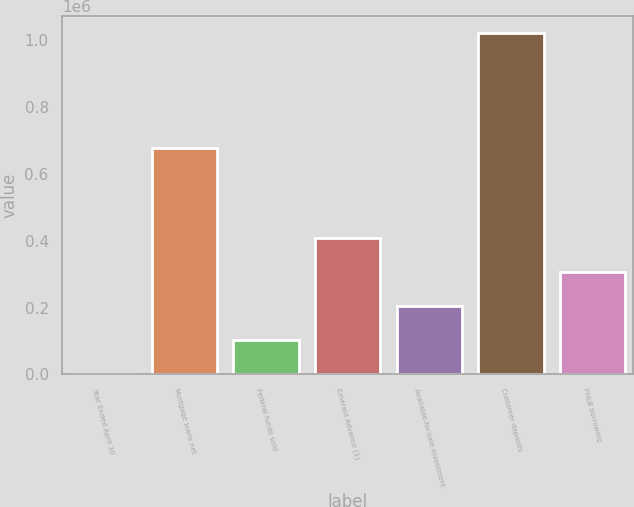Convert chart. <chart><loc_0><loc_0><loc_500><loc_500><bar_chart><fcel>Year Ended April 30<fcel>Mortgage loans net<fcel>Federal funds sold<fcel>Emerald Advance (1)<fcel>Available-for-sale investment<fcel>Customer deposits<fcel>FHLB borrowing<nl><fcel>2010<fcel>677115<fcel>103775<fcel>409072<fcel>205541<fcel>1.01966e+06<fcel>307306<nl></chart> 